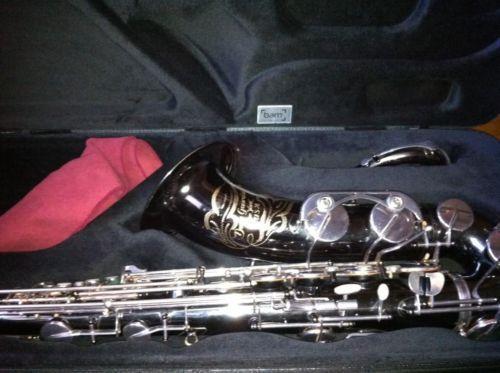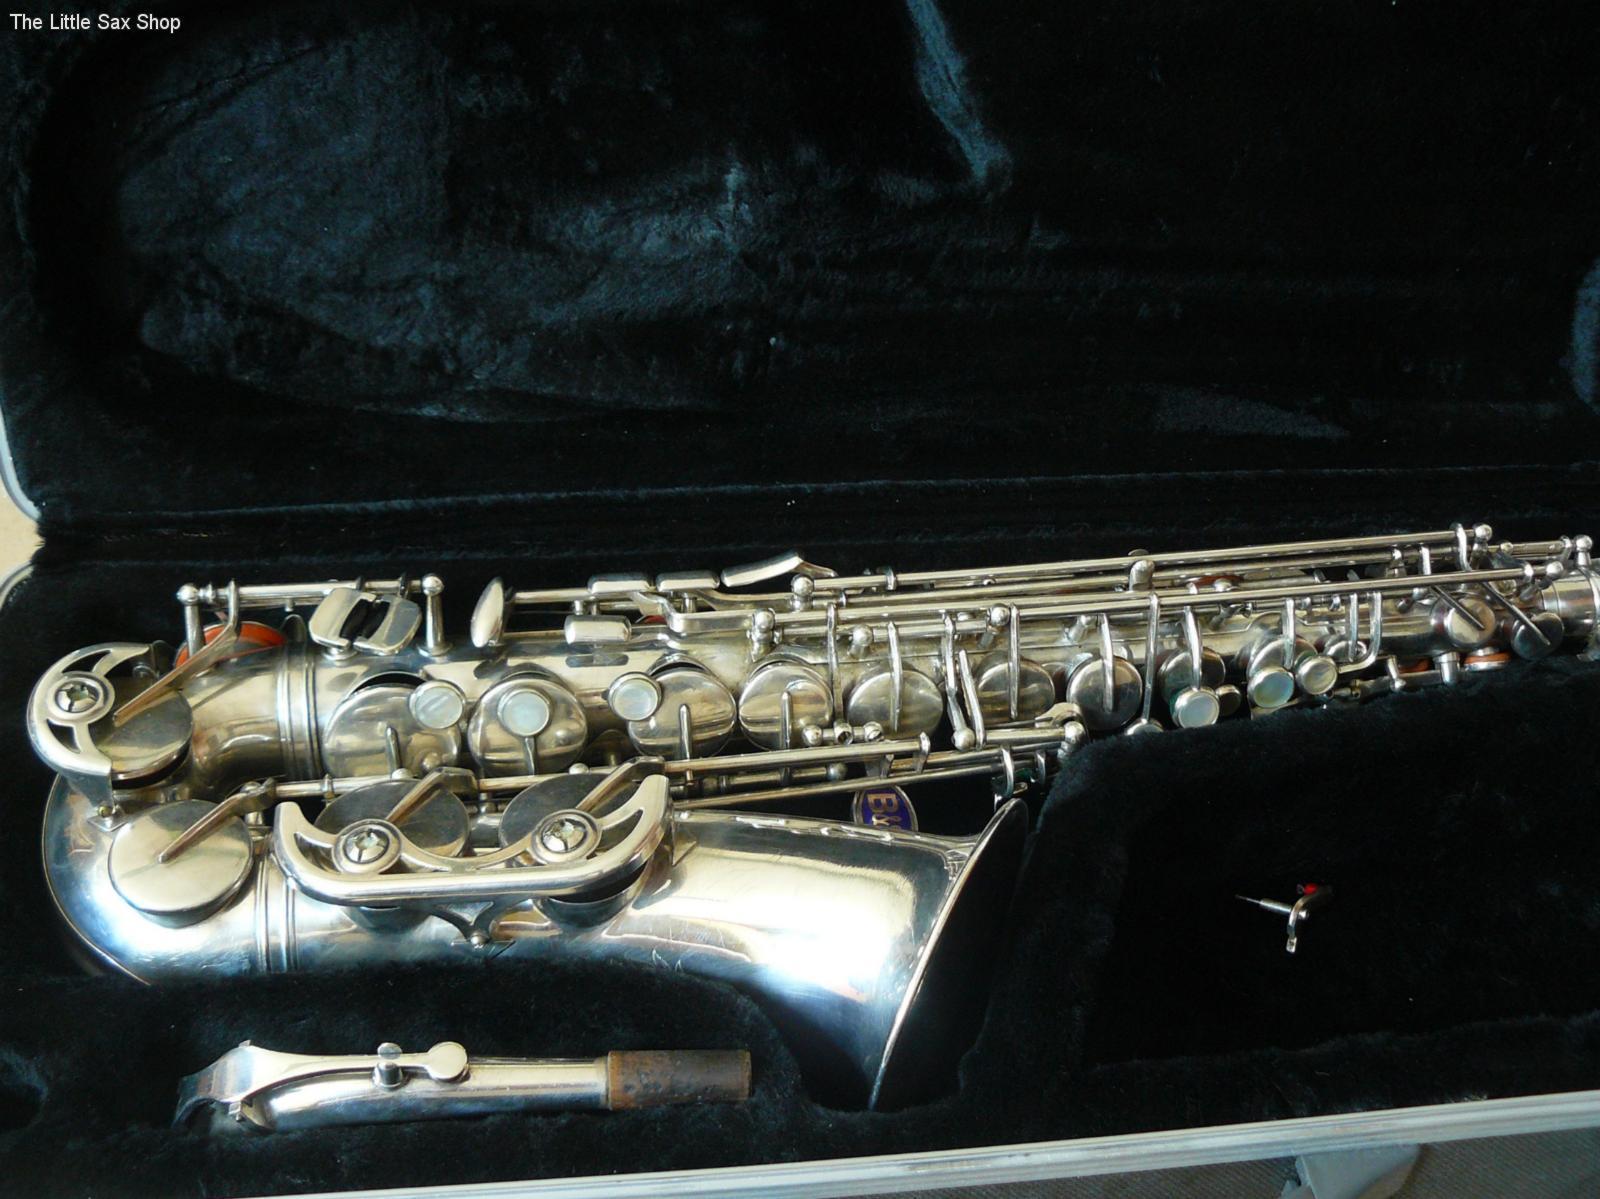The first image is the image on the left, the second image is the image on the right. For the images displayed, is the sentence "An image shows a gold-colored saxophone with floral etchings on the bell and a non-shiny exterior finish, displayed on black without wrinkles." factually correct? Answer yes or no. No. The first image is the image on the left, the second image is the image on the right. Considering the images on both sides, is "The saxophones are all sitting on black materials." valid? Answer yes or no. Yes. 